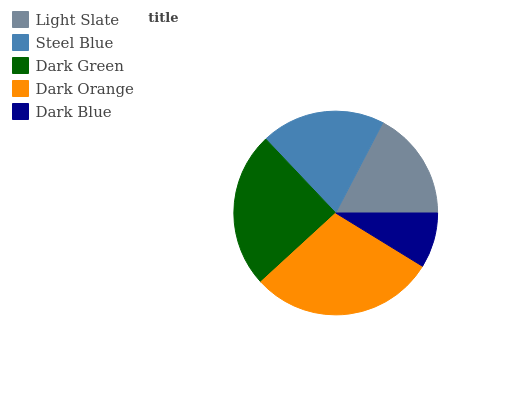Is Dark Blue the minimum?
Answer yes or no. Yes. Is Dark Orange the maximum?
Answer yes or no. Yes. Is Steel Blue the minimum?
Answer yes or no. No. Is Steel Blue the maximum?
Answer yes or no. No. Is Steel Blue greater than Light Slate?
Answer yes or no. Yes. Is Light Slate less than Steel Blue?
Answer yes or no. Yes. Is Light Slate greater than Steel Blue?
Answer yes or no. No. Is Steel Blue less than Light Slate?
Answer yes or no. No. Is Steel Blue the high median?
Answer yes or no. Yes. Is Steel Blue the low median?
Answer yes or no. Yes. Is Dark Orange the high median?
Answer yes or no. No. Is Light Slate the low median?
Answer yes or no. No. 